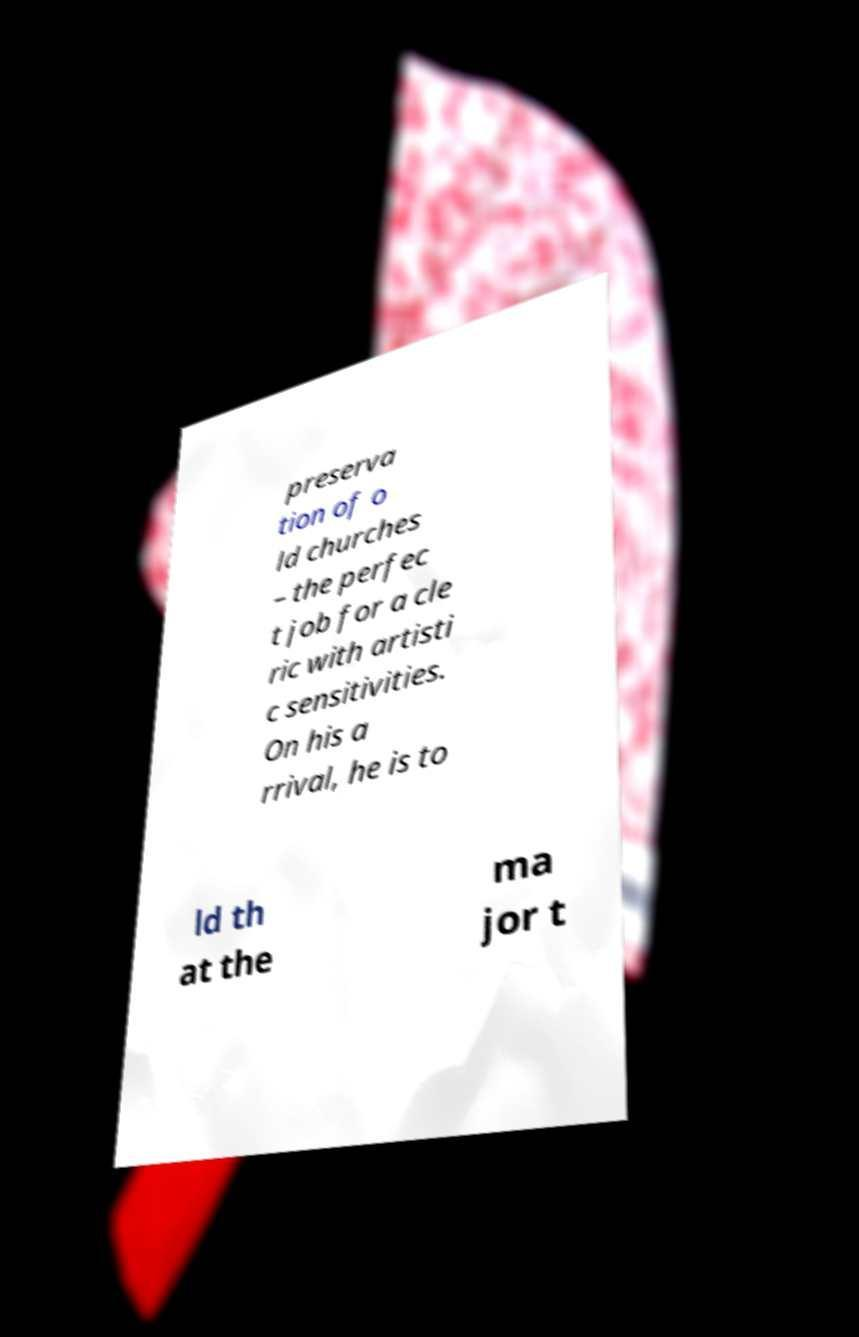Please identify and transcribe the text found in this image. preserva tion of o ld churches – the perfec t job for a cle ric with artisti c sensitivities. On his a rrival, he is to ld th at the ma jor t 